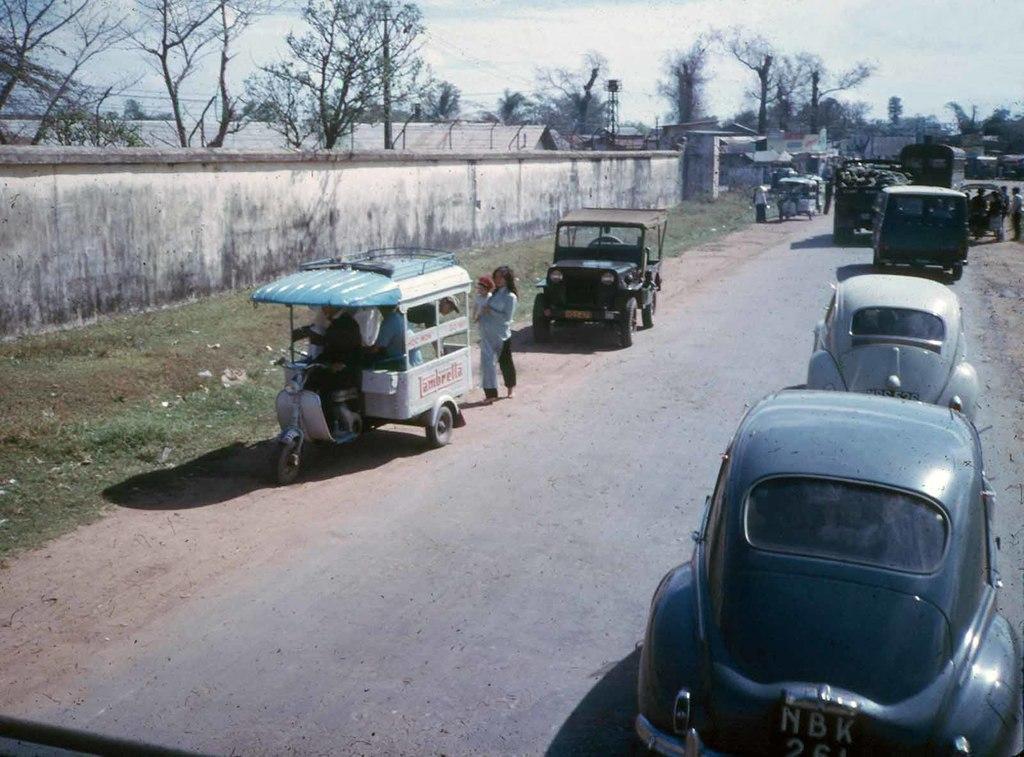Please provide a concise description of this image. In the picture I can see vehicles on the road and people standing on the ground. In the background I can see trees, fence, the grass, the sky and some other objects. 